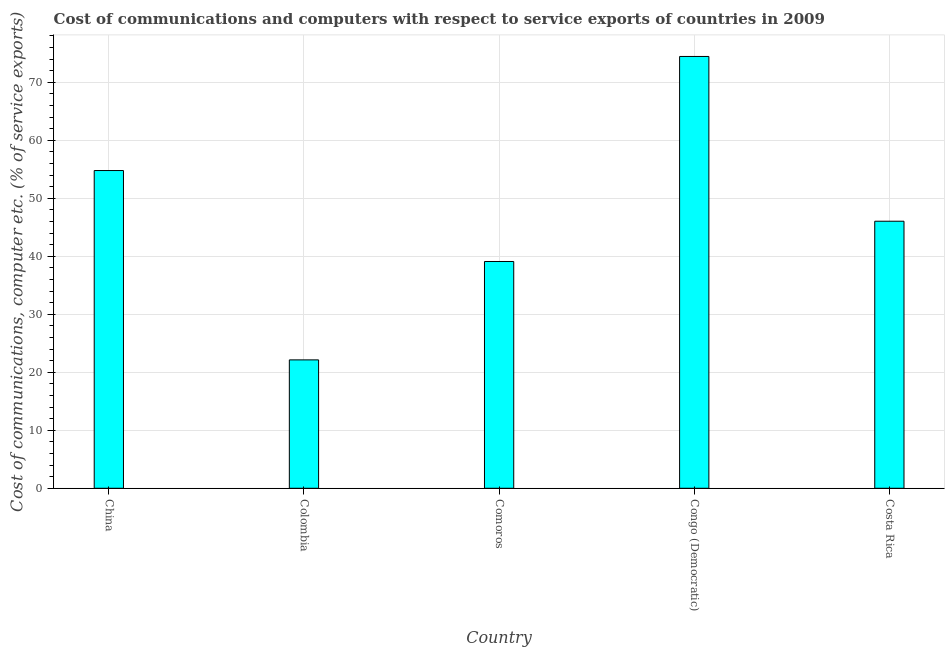Does the graph contain any zero values?
Your answer should be compact. No. Does the graph contain grids?
Your answer should be very brief. Yes. What is the title of the graph?
Your response must be concise. Cost of communications and computers with respect to service exports of countries in 2009. What is the label or title of the Y-axis?
Ensure brevity in your answer.  Cost of communications, computer etc. (% of service exports). What is the cost of communications and computer in Colombia?
Provide a succinct answer. 22.14. Across all countries, what is the maximum cost of communications and computer?
Provide a succinct answer. 74.44. Across all countries, what is the minimum cost of communications and computer?
Provide a succinct answer. 22.14. In which country was the cost of communications and computer maximum?
Your answer should be very brief. Congo (Democratic). In which country was the cost of communications and computer minimum?
Keep it short and to the point. Colombia. What is the sum of the cost of communications and computer?
Keep it short and to the point. 236.49. What is the difference between the cost of communications and computer in China and Comoros?
Give a very brief answer. 15.68. What is the average cost of communications and computer per country?
Make the answer very short. 47.3. What is the median cost of communications and computer?
Provide a short and direct response. 46.04. What is the ratio of the cost of communications and computer in Colombia to that in Congo (Democratic)?
Your answer should be compact. 0.3. Is the cost of communications and computer in China less than that in Colombia?
Keep it short and to the point. No. What is the difference between the highest and the second highest cost of communications and computer?
Give a very brief answer. 19.66. What is the difference between the highest and the lowest cost of communications and computer?
Keep it short and to the point. 52.31. How many bars are there?
Provide a short and direct response. 5. Are all the bars in the graph horizontal?
Your answer should be compact. No. How many countries are there in the graph?
Give a very brief answer. 5. What is the difference between two consecutive major ticks on the Y-axis?
Your response must be concise. 10. What is the Cost of communications, computer etc. (% of service exports) in China?
Make the answer very short. 54.78. What is the Cost of communications, computer etc. (% of service exports) of Colombia?
Ensure brevity in your answer.  22.14. What is the Cost of communications, computer etc. (% of service exports) in Comoros?
Your answer should be compact. 39.1. What is the Cost of communications, computer etc. (% of service exports) of Congo (Democratic)?
Keep it short and to the point. 74.44. What is the Cost of communications, computer etc. (% of service exports) of Costa Rica?
Your answer should be very brief. 46.04. What is the difference between the Cost of communications, computer etc. (% of service exports) in China and Colombia?
Make the answer very short. 32.64. What is the difference between the Cost of communications, computer etc. (% of service exports) in China and Comoros?
Provide a succinct answer. 15.68. What is the difference between the Cost of communications, computer etc. (% of service exports) in China and Congo (Democratic)?
Your answer should be compact. -19.66. What is the difference between the Cost of communications, computer etc. (% of service exports) in China and Costa Rica?
Make the answer very short. 8.74. What is the difference between the Cost of communications, computer etc. (% of service exports) in Colombia and Comoros?
Provide a succinct answer. -16.96. What is the difference between the Cost of communications, computer etc. (% of service exports) in Colombia and Congo (Democratic)?
Your answer should be very brief. -52.31. What is the difference between the Cost of communications, computer etc. (% of service exports) in Colombia and Costa Rica?
Provide a short and direct response. -23.9. What is the difference between the Cost of communications, computer etc. (% of service exports) in Comoros and Congo (Democratic)?
Your answer should be very brief. -35.34. What is the difference between the Cost of communications, computer etc. (% of service exports) in Comoros and Costa Rica?
Make the answer very short. -6.94. What is the difference between the Cost of communications, computer etc. (% of service exports) in Congo (Democratic) and Costa Rica?
Ensure brevity in your answer.  28.4. What is the ratio of the Cost of communications, computer etc. (% of service exports) in China to that in Colombia?
Make the answer very short. 2.48. What is the ratio of the Cost of communications, computer etc. (% of service exports) in China to that in Comoros?
Your response must be concise. 1.4. What is the ratio of the Cost of communications, computer etc. (% of service exports) in China to that in Congo (Democratic)?
Offer a terse response. 0.74. What is the ratio of the Cost of communications, computer etc. (% of service exports) in China to that in Costa Rica?
Keep it short and to the point. 1.19. What is the ratio of the Cost of communications, computer etc. (% of service exports) in Colombia to that in Comoros?
Keep it short and to the point. 0.57. What is the ratio of the Cost of communications, computer etc. (% of service exports) in Colombia to that in Congo (Democratic)?
Provide a short and direct response. 0.3. What is the ratio of the Cost of communications, computer etc. (% of service exports) in Colombia to that in Costa Rica?
Ensure brevity in your answer.  0.48. What is the ratio of the Cost of communications, computer etc. (% of service exports) in Comoros to that in Congo (Democratic)?
Make the answer very short. 0.53. What is the ratio of the Cost of communications, computer etc. (% of service exports) in Comoros to that in Costa Rica?
Make the answer very short. 0.85. What is the ratio of the Cost of communications, computer etc. (% of service exports) in Congo (Democratic) to that in Costa Rica?
Offer a very short reply. 1.62. 